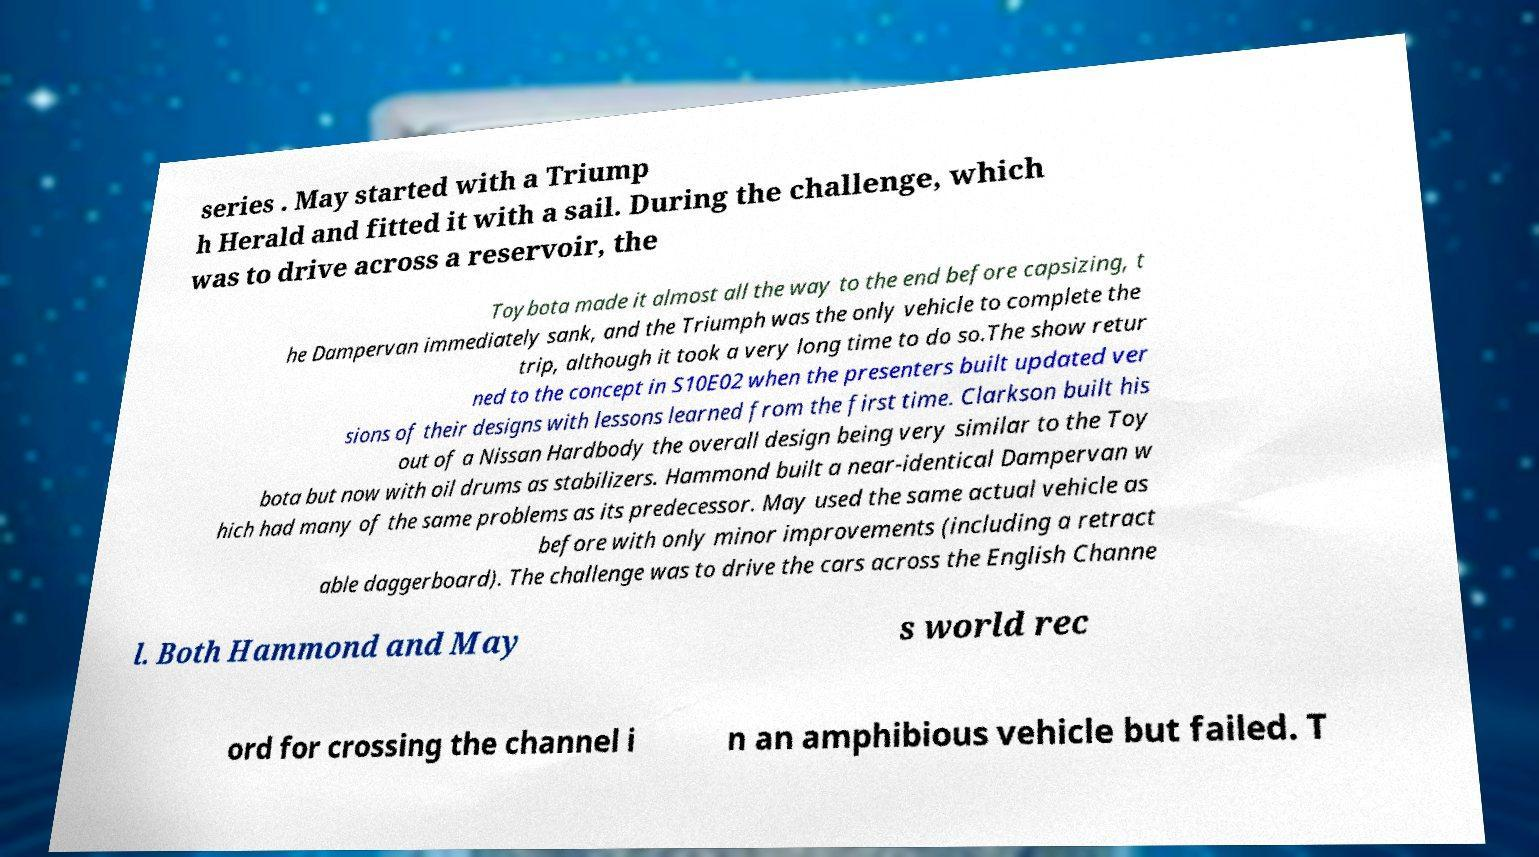For documentation purposes, I need the text within this image transcribed. Could you provide that? series . May started with a Triump h Herald and fitted it with a sail. During the challenge, which was to drive across a reservoir, the Toybota made it almost all the way to the end before capsizing, t he Dampervan immediately sank, and the Triumph was the only vehicle to complete the trip, although it took a very long time to do so.The show retur ned to the concept in S10E02 when the presenters built updated ver sions of their designs with lessons learned from the first time. Clarkson built his out of a Nissan Hardbody the overall design being very similar to the Toy bota but now with oil drums as stabilizers. Hammond built a near-identical Dampervan w hich had many of the same problems as its predecessor. May used the same actual vehicle as before with only minor improvements (including a retract able daggerboard). The challenge was to drive the cars across the English Channe l. Both Hammond and May s world rec ord for crossing the channel i n an amphibious vehicle but failed. T 